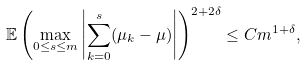<formula> <loc_0><loc_0><loc_500><loc_500>\mathbb { E } \left ( \max _ { 0 \leq s \leq m } \left | \sum _ { k = 0 } ^ { s } ( \mu _ { k } - \mu ) \right | \right ) ^ { 2 + 2 \delta } \leq C m ^ { 1 + \delta } ,</formula> 